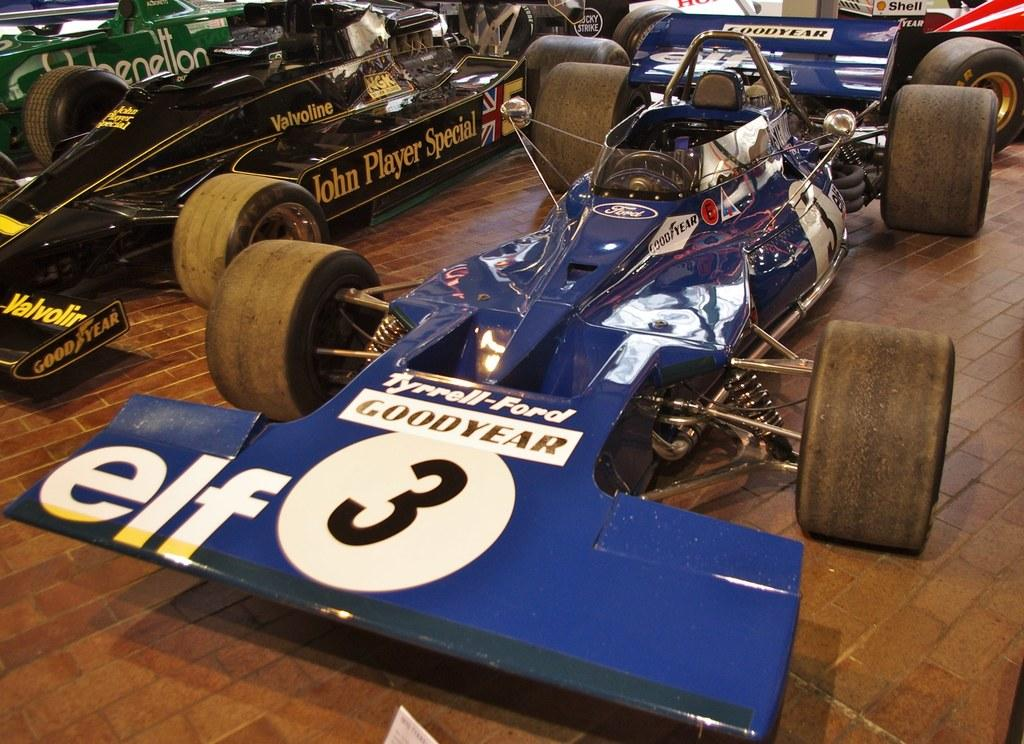What type of vehicles are present in the image? There are sports cars in the image. Where are the sports cars located? The sports cars are placed on the floor. What type of steel is used to construct the sneeze in the image? There is no sneeze present in the image, and therefore no steel construction is involved. 